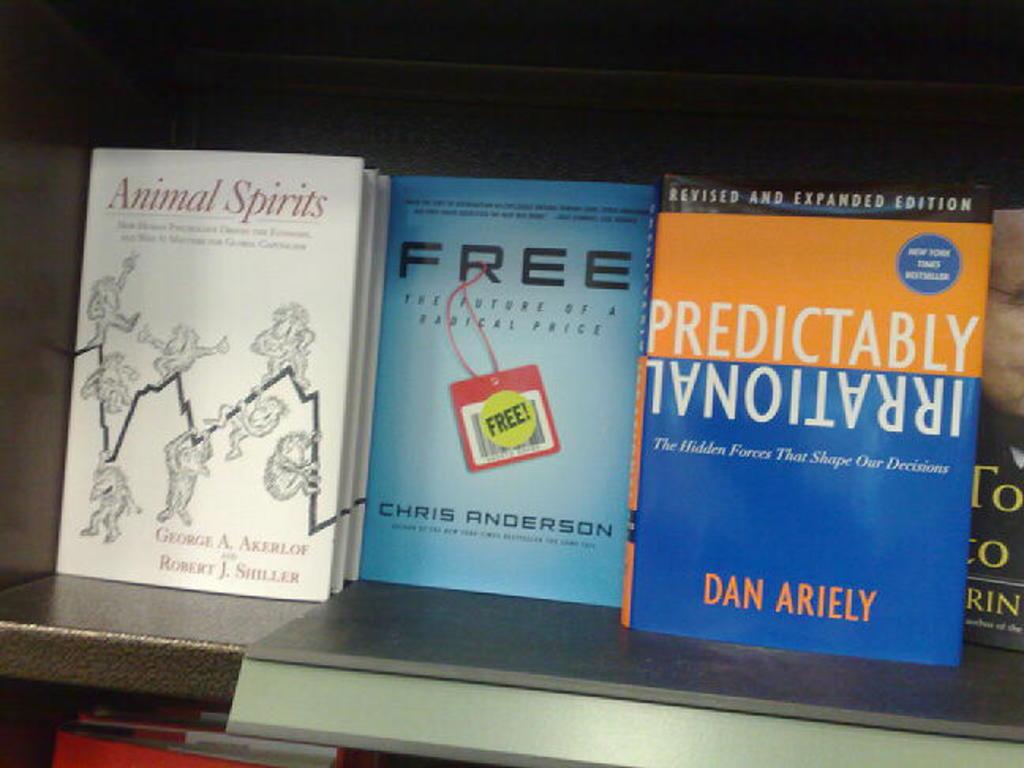What is the title of the book to the very left?
Provide a short and direct response. Animal spirits. 